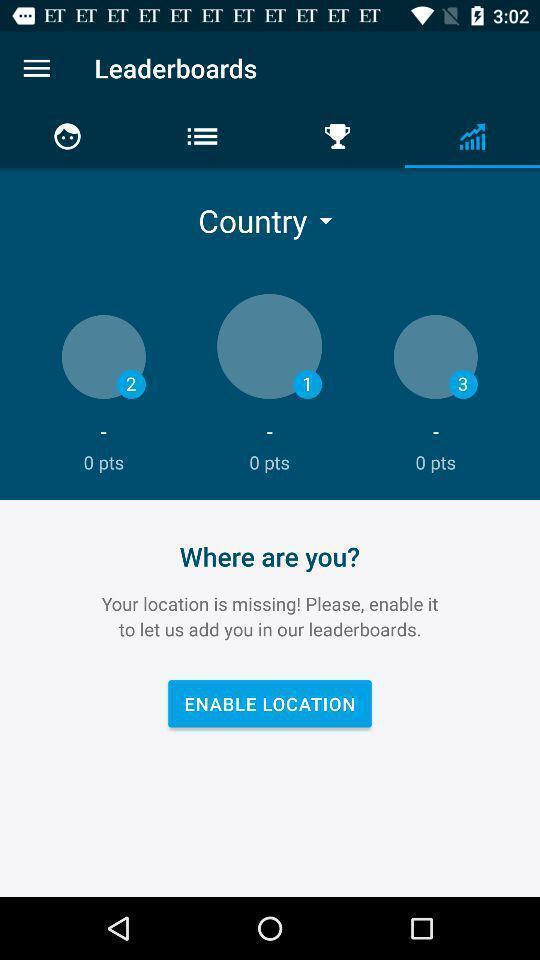Describe this image in words. Scoreboards page in a wifi networking app. 